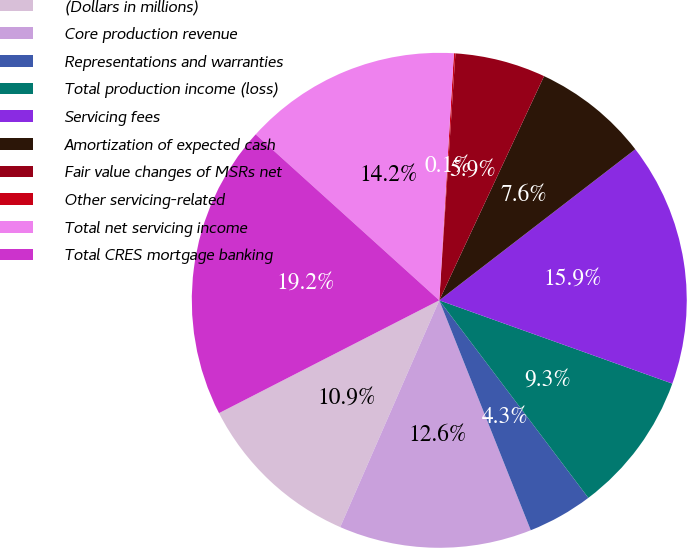<chart> <loc_0><loc_0><loc_500><loc_500><pie_chart><fcel>(Dollars in millions)<fcel>Core production revenue<fcel>Representations and warranties<fcel>Total production income (loss)<fcel>Servicing fees<fcel>Amortization of expected cash<fcel>Fair value changes of MSRs net<fcel>Other servicing-related<fcel>Total net servicing income<fcel>Total CRES mortgage banking<nl><fcel>10.91%<fcel>12.58%<fcel>4.26%<fcel>9.25%<fcel>15.91%<fcel>7.59%<fcel>5.92%<fcel>0.1%<fcel>14.24%<fcel>19.23%<nl></chart> 